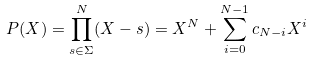<formula> <loc_0><loc_0><loc_500><loc_500>P ( X ) = \prod _ { s \in \Sigma } ^ { N } ( X - s ) = X ^ { N } + \sum _ { i = 0 } ^ { N - 1 } c _ { N - i } X ^ { i }</formula> 